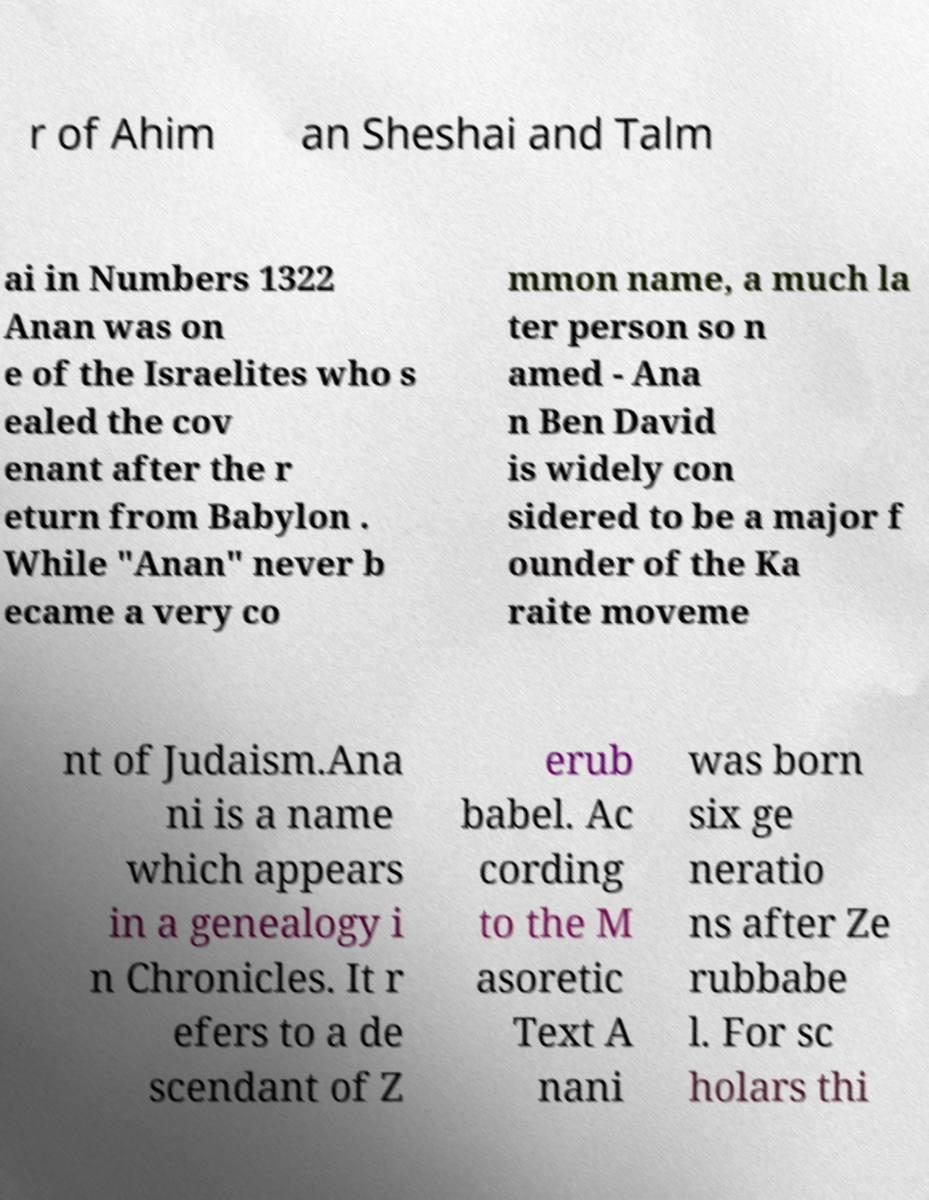Please read and relay the text visible in this image. What does it say? r of Ahim an Sheshai and Talm ai in Numbers 1322 Anan was on e of the Israelites who s ealed the cov enant after the r eturn from Babylon . While "Anan" never b ecame a very co mmon name, a much la ter person so n amed - Ana n Ben David is widely con sidered to be a major f ounder of the Ka raite moveme nt of Judaism.Ana ni is a name which appears in a genealogy i n Chronicles. It r efers to a de scendant of Z erub babel. Ac cording to the M asoretic Text A nani was born six ge neratio ns after Ze rubbabe l. For sc holars thi 